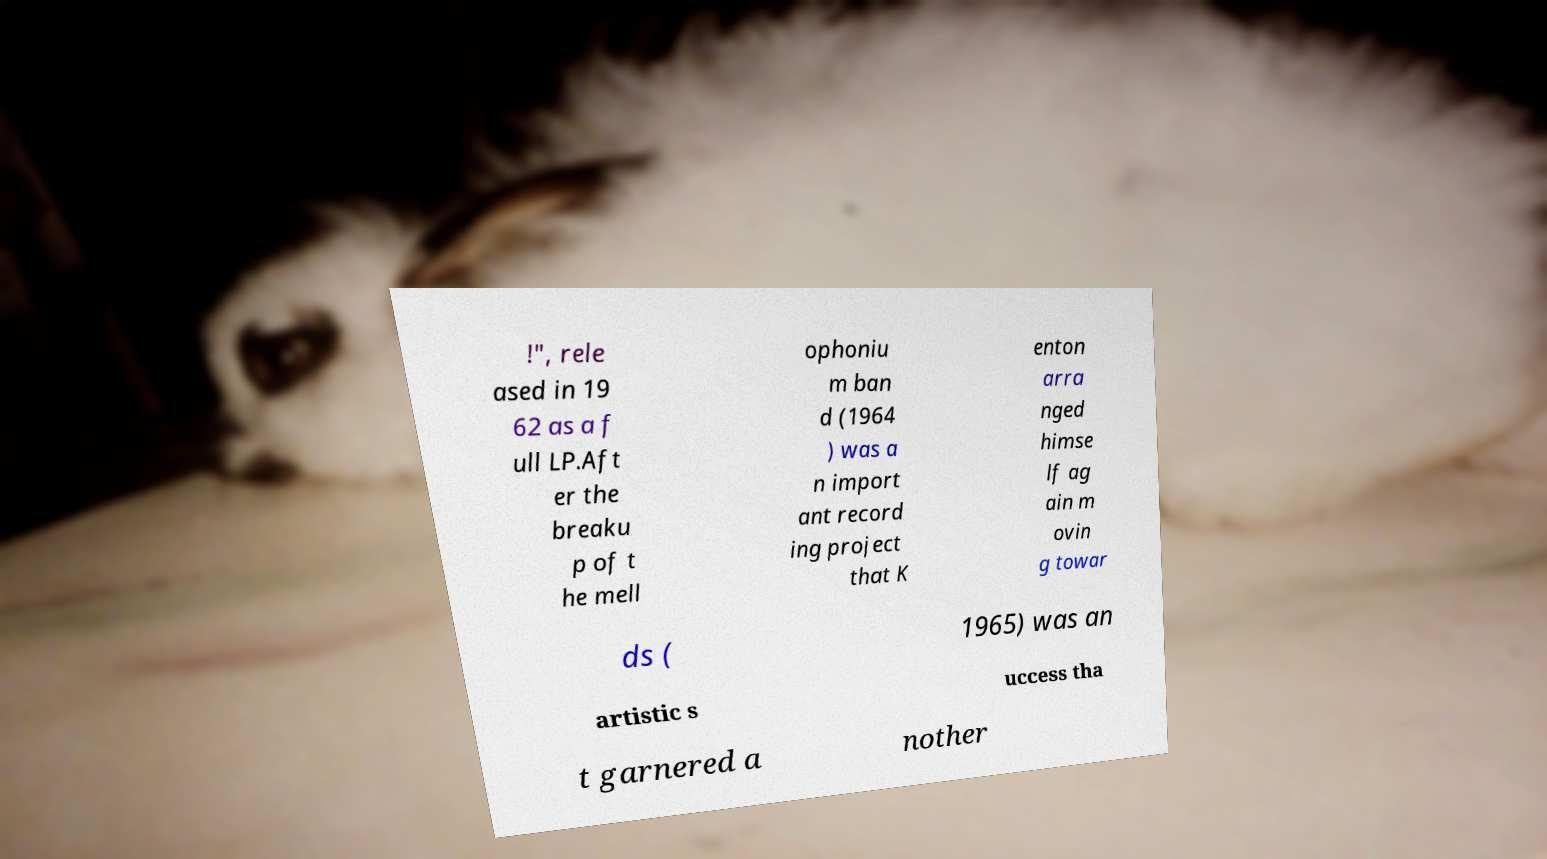Please read and relay the text visible in this image. What does it say? !", rele ased in 19 62 as a f ull LP.Aft er the breaku p of t he mell ophoniu m ban d (1964 ) was a n import ant record ing project that K enton arra nged himse lf ag ain m ovin g towar ds ( 1965) was an artistic s uccess tha t garnered a nother 